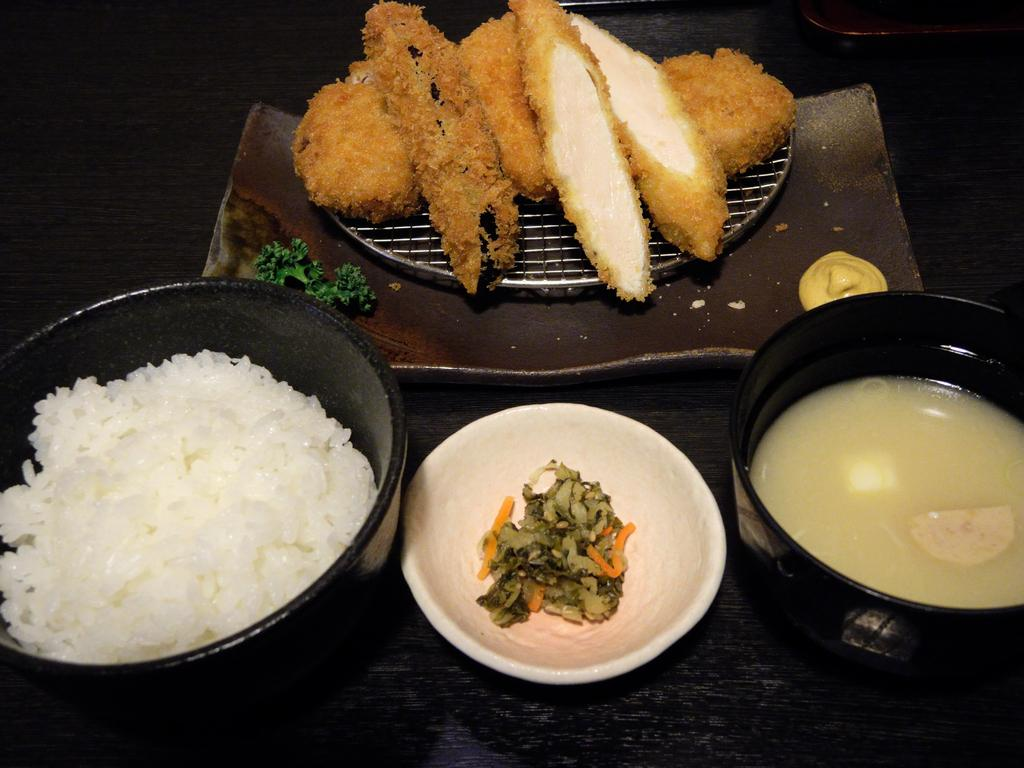What type of food items can be seen in the image? There are food items in bowls in the image. Can you describe the non-veg pieces in the image? There are non-veg pieces on a grill in the image. How many clocks are hanging on the wall in the image? There are no clocks visible in the image. What type of wine is being served with the food in the image? There is no wine present in the image. 